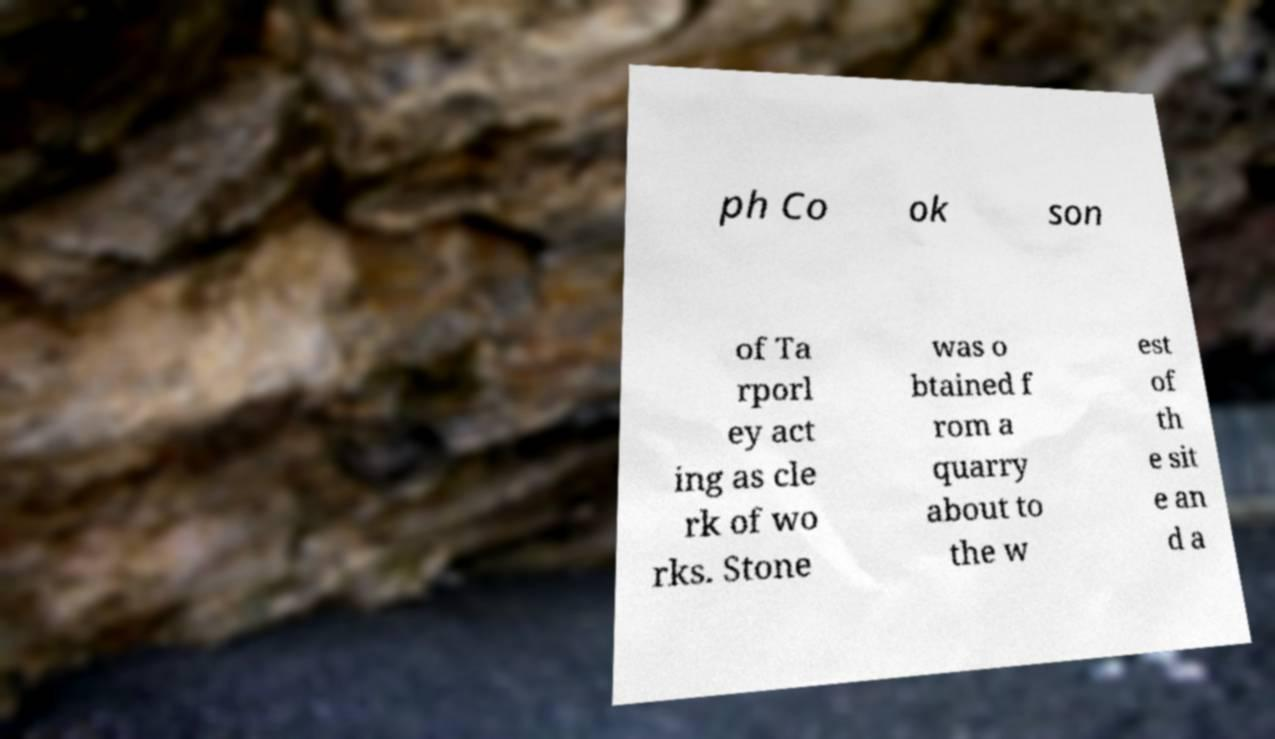I need the written content from this picture converted into text. Can you do that? ph Co ok son of Ta rporl ey act ing as cle rk of wo rks. Stone was o btained f rom a quarry about to the w est of th e sit e an d a 